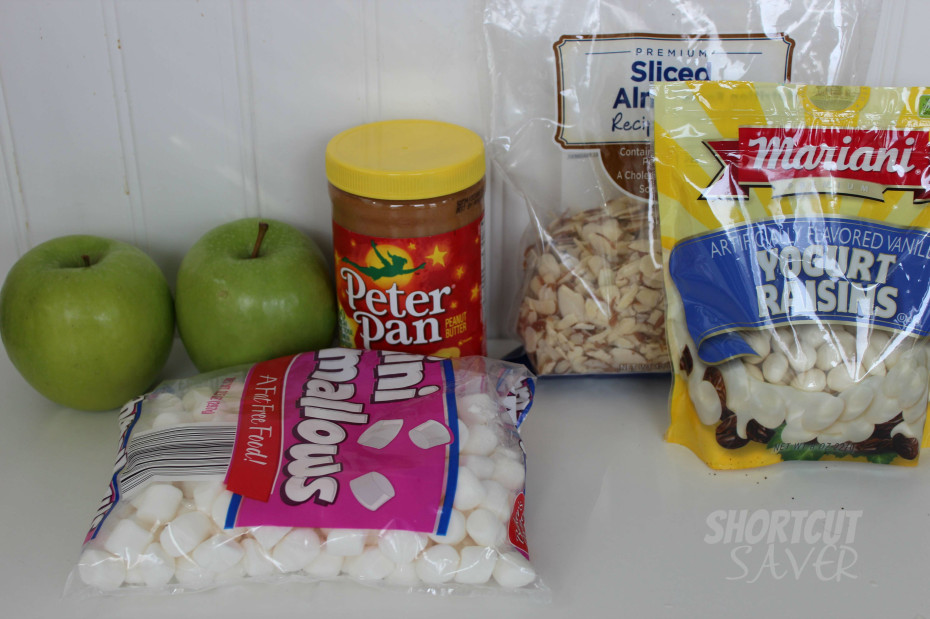Given the combination of items, what kind of recipe or dish might be intended to be prepared with these ingredients? The array of items in the image, including apples, peanut butter, marshmallows, sliced almonds, and yogurt-covered raisins, suggests a playful and versatile approach to sweet treats. One specific recipe that could be crafted from these ingredients is a delightful 'Apple-Peanut Butter Delight'. First, slice the apples into rounds and remove the core to create doughnut-like shapes. Spread peanut butter on one side of each apple slice, then sprinkle with almonds and mini marshmallows. Next, scatter yogurt-covered raisins atop as a sweet, tangy finish. This treat offers a perfect balance of crispy, creamy, and chewy textures, suitable for an afterschool snack or a casual dessert. It's not only easy to assemble but also a fun way to enjoy a mix of wholesome and indulgent flavors. 